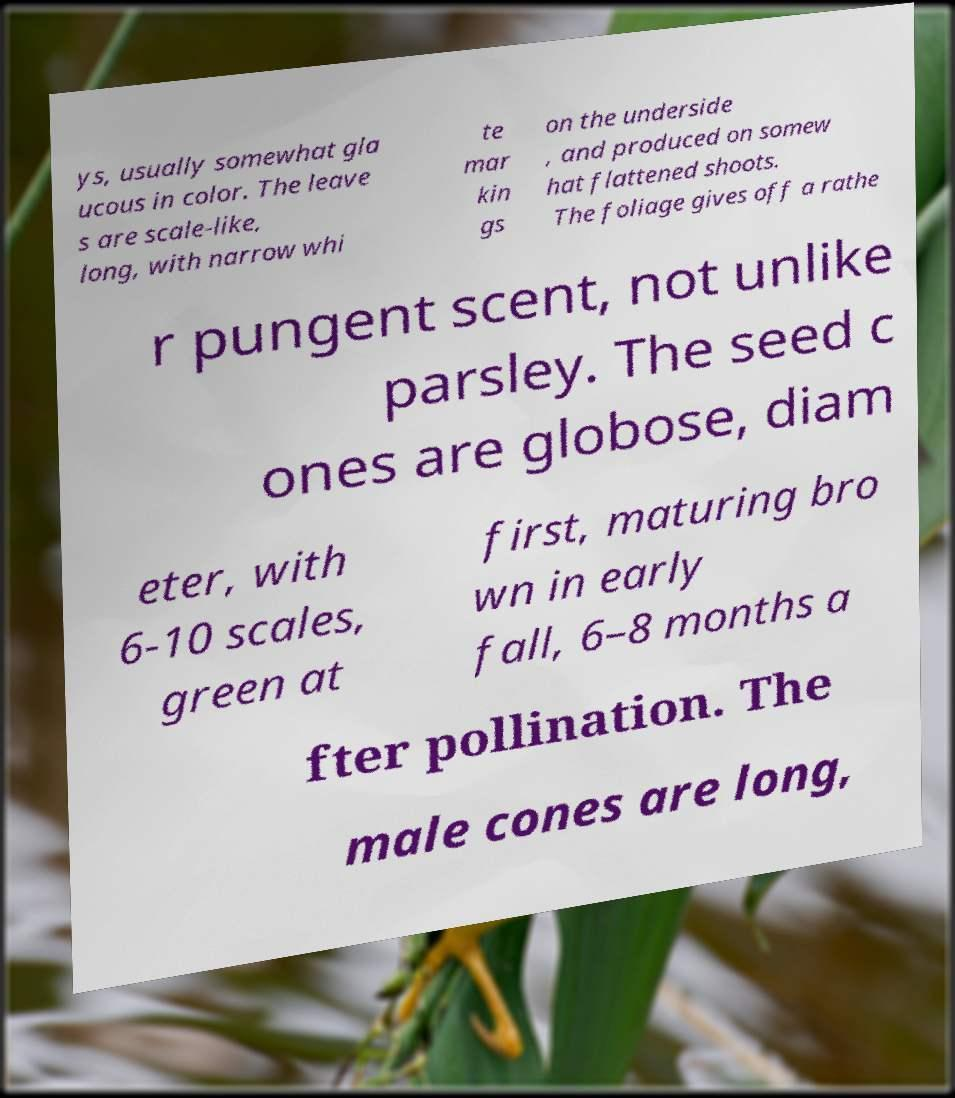What messages or text are displayed in this image? I need them in a readable, typed format. ys, usually somewhat gla ucous in color. The leave s are scale-like, long, with narrow whi te mar kin gs on the underside , and produced on somew hat flattened shoots. The foliage gives off a rathe r pungent scent, not unlike parsley. The seed c ones are globose, diam eter, with 6-10 scales, green at first, maturing bro wn in early fall, 6–8 months a fter pollination. The male cones are long, 